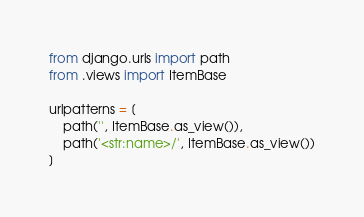Convert code to text. <code><loc_0><loc_0><loc_500><loc_500><_Python_>from django.urls import path
from .views import ItemBase

urlpatterns = [
    path('', ItemBase.as_view()),
    path('<str:name>/', ItemBase.as_view())
]</code> 